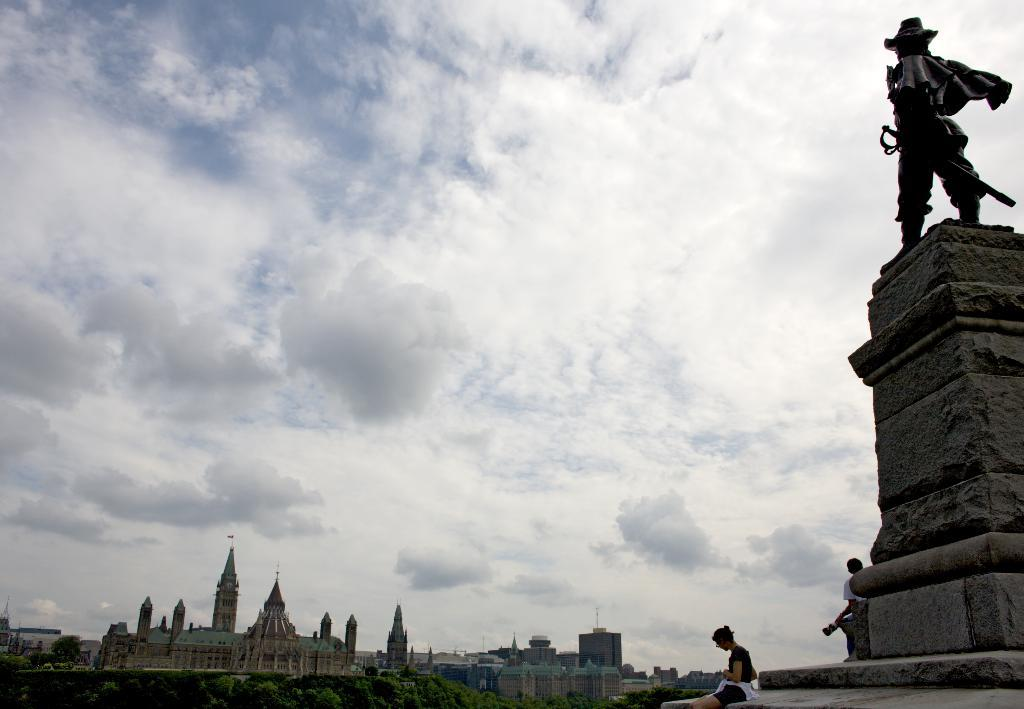What is the main subject of the image? The main subject of the image is a statue. Where is the statue located? The statue is on a pedestal. What are people doing in relation to the statue? There are persons sitting and standing on the pedestal. What other structures can be seen in the image? There are buildings in the image. Are there any symbols or emblems visible in the image? Yes, there are flags in the image. What can be seen in the background of the image? Trees and the sky are visible in the background of the image. What is the condition of the sky in the image? The sky has clouds present in it. What type of engine can be seen powering the statue in the image? There is no engine present in the image, and the statue is not powered by any engine. How many legs does the statue have in the image? The statue is a sculpture and does not have legs; it is a solid object. 